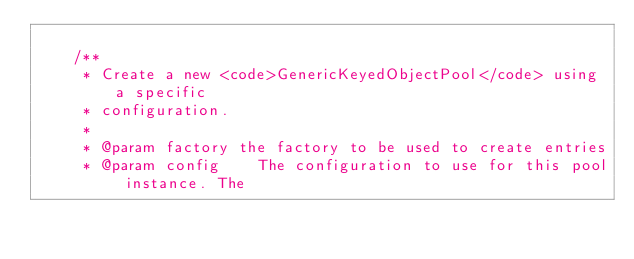Convert code to text. <code><loc_0><loc_0><loc_500><loc_500><_Java_>
    /**
     * Create a new <code>GenericKeyedObjectPool</code> using a specific
     * configuration.
     *
     * @param factory the factory to be used to create entries
     * @param config    The configuration to use for this pool instance. The</code> 